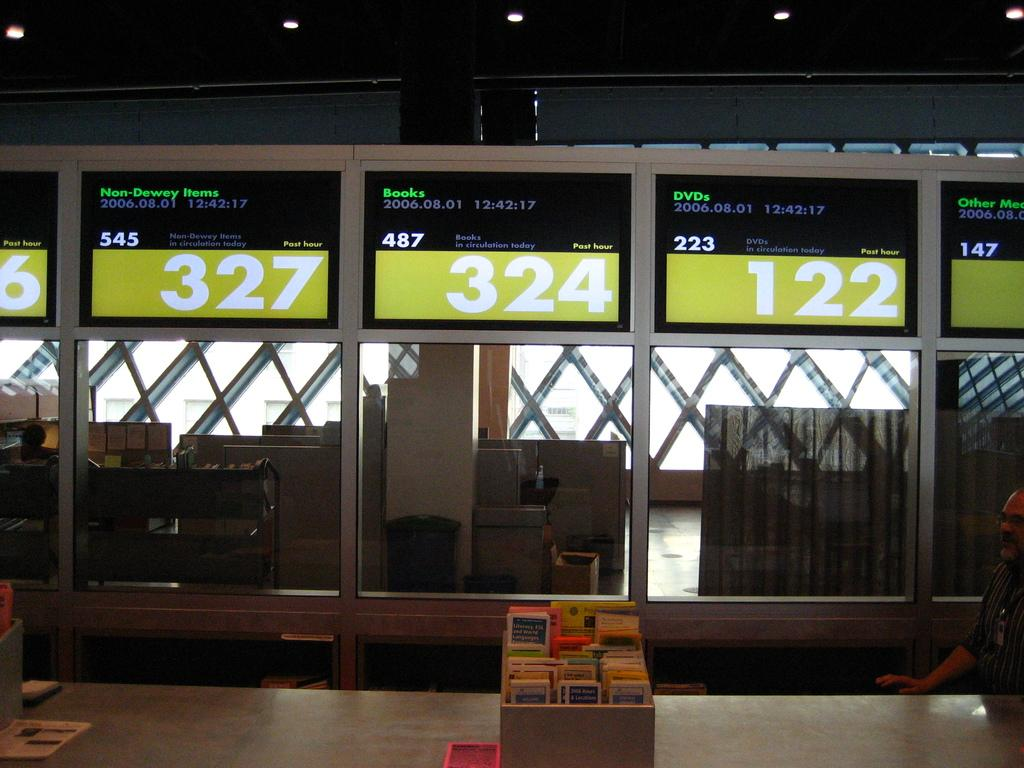Who or what is present in the image? There is a person in the image. What objects are related to books in the image? There are wooden boxes containing books in the image. What items are on the table in the image? There are papers on a table in the image. What type of electronic devices are in the image? There are screens in the image. What type of structures are in the image? There are cabins in the image. What type of storage units are in the image? There are racks in the image. What type of illumination is in the image? There are lights in the image. What type of wing is visible on the scarecrow in the image? There is no scarecrow or wing present in the image. What type of parent is shown interacting with the person in the image? There is no parent or interaction with a person in the image. 